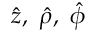<formula> <loc_0><loc_0><loc_500><loc_500>\hat { z } , \hat { \rho } , \hat { \phi }</formula> 